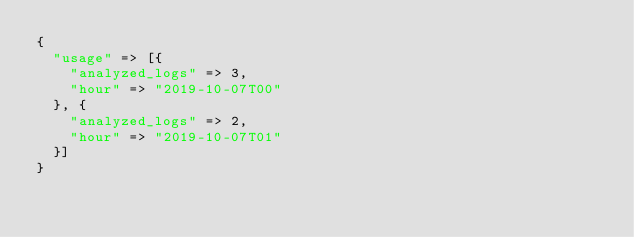Convert code to text. <code><loc_0><loc_0><loc_500><loc_500><_Ruby_>{
  "usage" => [{
    "analyzed_logs" => 3,
    "hour" => "2019-10-07T00"
  }, {
    "analyzed_logs" => 2,
    "hour" => "2019-10-07T01"
  }]
}</code> 